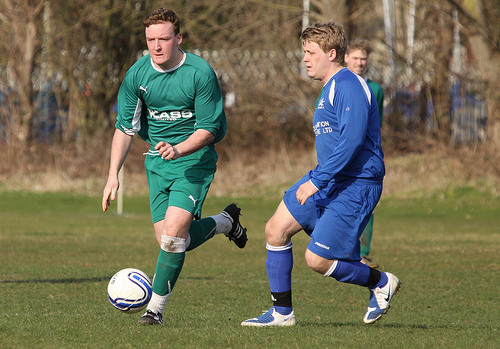<image>
Is there a shirt on the man? No. The shirt is not positioned on the man. They may be near each other, but the shirt is not supported by or resting on top of the man. Is there a man to the left of the man? Yes. From this viewpoint, the man is positioned to the left side relative to the man. 